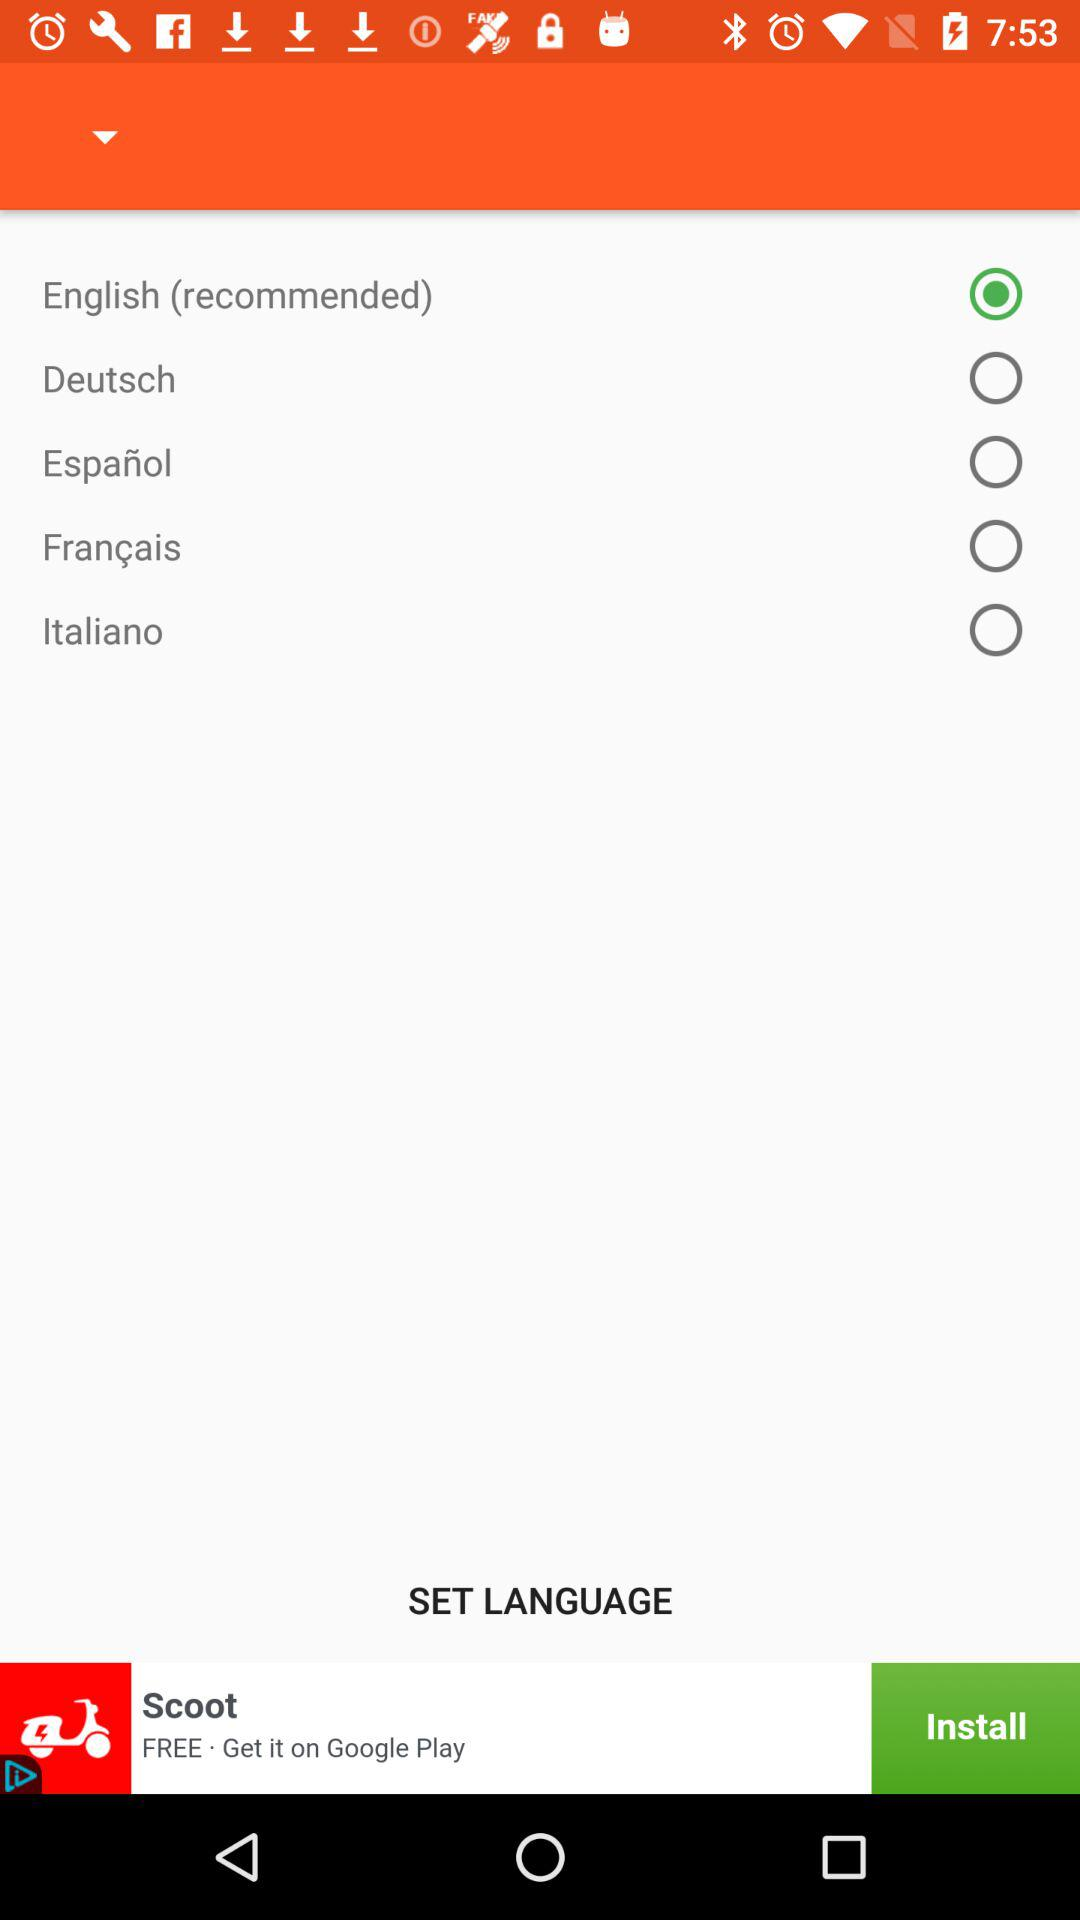How many languages are there to choose from?
Answer the question using a single word or phrase. 5 